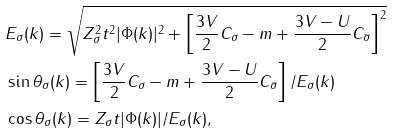<formula> <loc_0><loc_0><loc_500><loc_500>& E _ { \sigma } ( k ) = \sqrt { Z _ { \sigma } ^ { 2 } t ^ { 2 } | \Phi ( k ) | ^ { 2 } + \left [ \frac { 3 V } { 2 } C _ { \sigma } - m + \frac { 3 V - U } { 2 } C _ { \bar { \sigma } } \right ] ^ { 2 } } \\ & \sin \theta _ { \sigma } ( k ) = \left [ \frac { 3 V } { 2 } C _ { \sigma } - m + \frac { 3 V - U } { 2 } C _ { \bar { \sigma } } \right ] / E _ { \sigma } ( k ) \\ & \cos \theta _ { \sigma } ( k ) = Z _ { \sigma } t | \Phi ( k ) | / E _ { \sigma } ( k ) ,</formula> 